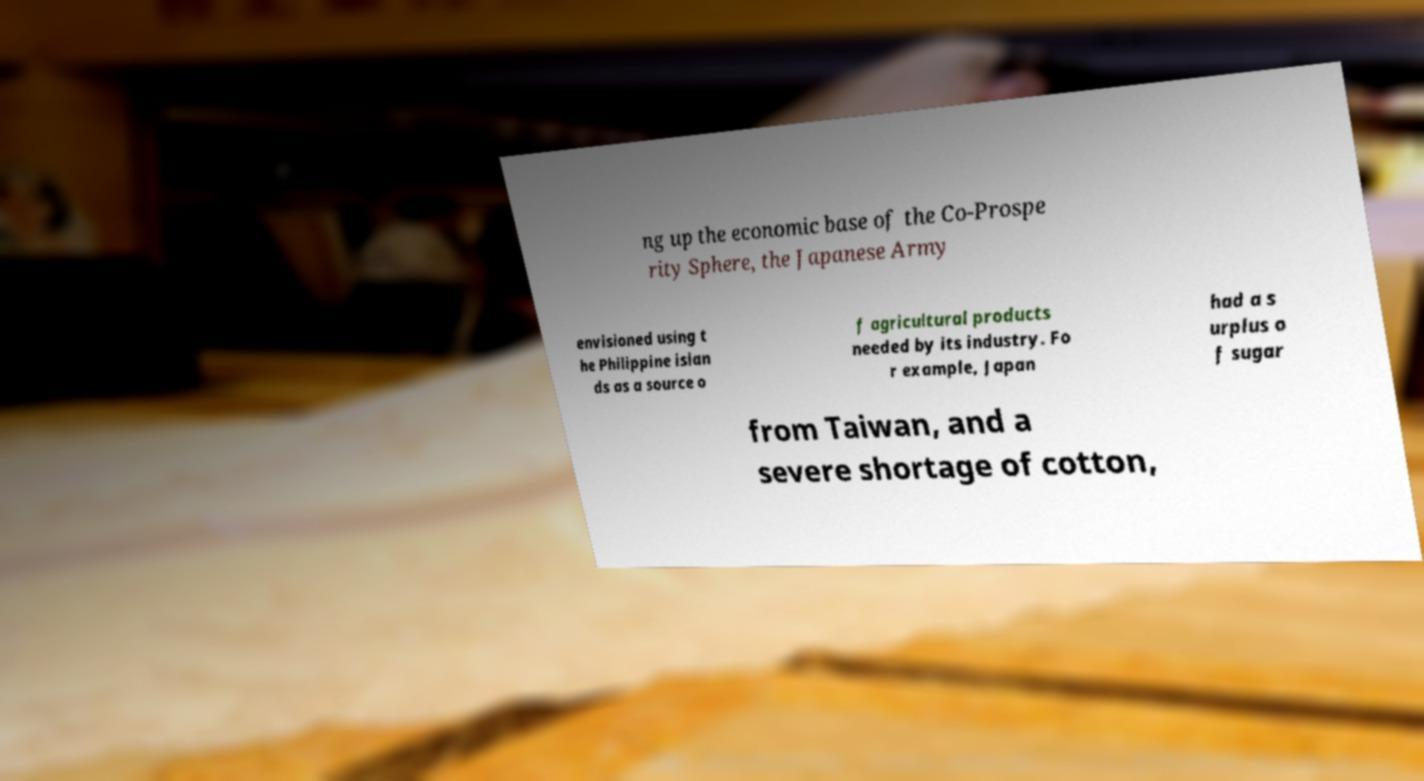Could you extract and type out the text from this image? ng up the economic base of the Co-Prospe rity Sphere, the Japanese Army envisioned using t he Philippine islan ds as a source o f agricultural products needed by its industry. Fo r example, Japan had a s urplus o f sugar from Taiwan, and a severe shortage of cotton, 